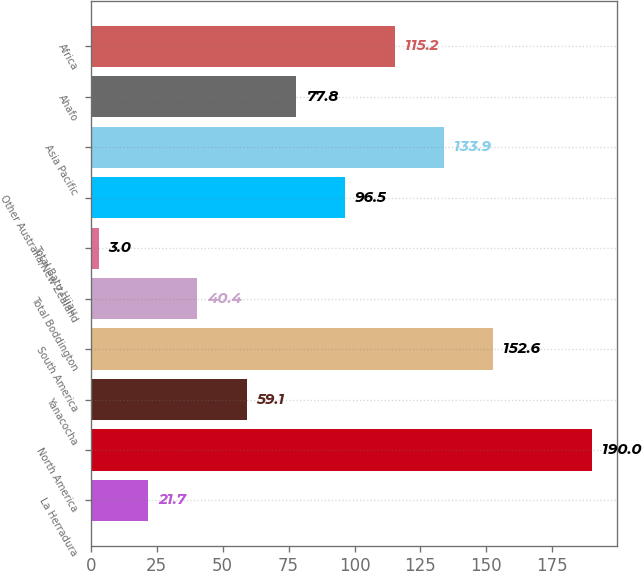<chart> <loc_0><loc_0><loc_500><loc_500><bar_chart><fcel>La Herradura<fcel>North America<fcel>Yanacocha<fcel>South America<fcel>Total Boddington<fcel>Total Batu Hijau<fcel>Other Australia/New Zealand<fcel>Asia Pacific<fcel>Ahafo<fcel>Africa<nl><fcel>21.7<fcel>190<fcel>59.1<fcel>152.6<fcel>40.4<fcel>3<fcel>96.5<fcel>133.9<fcel>77.8<fcel>115.2<nl></chart> 